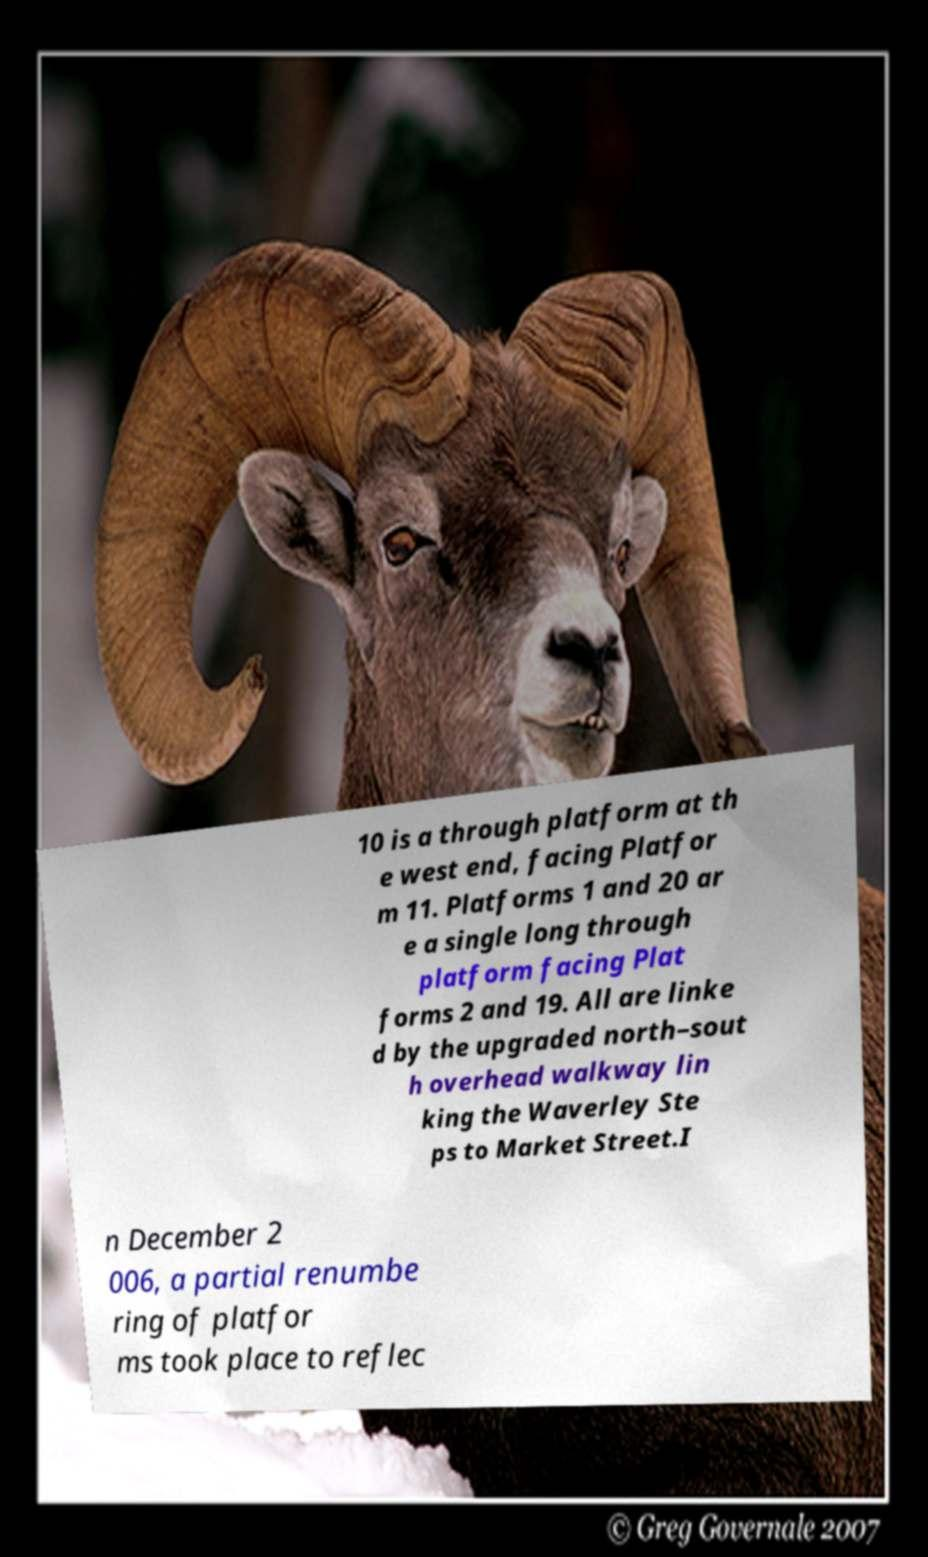What messages or text are displayed in this image? I need them in a readable, typed format. 10 is a through platform at th e west end, facing Platfor m 11. Platforms 1 and 20 ar e a single long through platform facing Plat forms 2 and 19. All are linke d by the upgraded north–sout h overhead walkway lin king the Waverley Ste ps to Market Street.I n December 2 006, a partial renumbe ring of platfor ms took place to reflec 